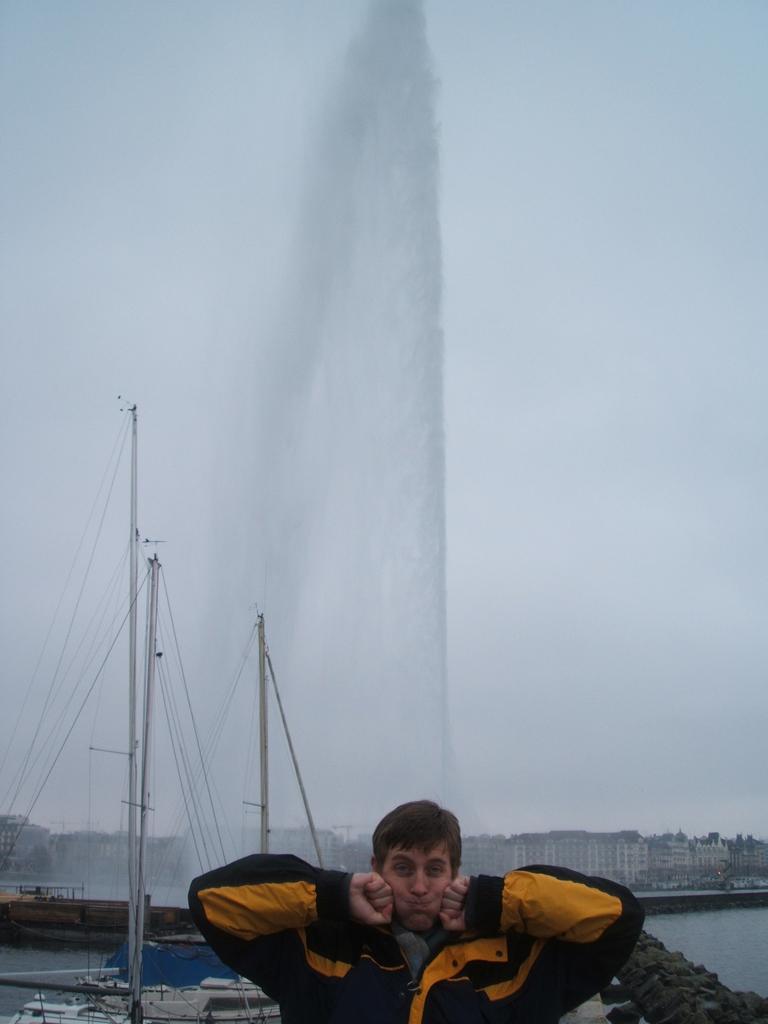Can you describe this image briefly? In this picture there is a person wearing black and yellow color jacket placed both of his hands on his cheeks and there are few boats,buildings and water in the background. 